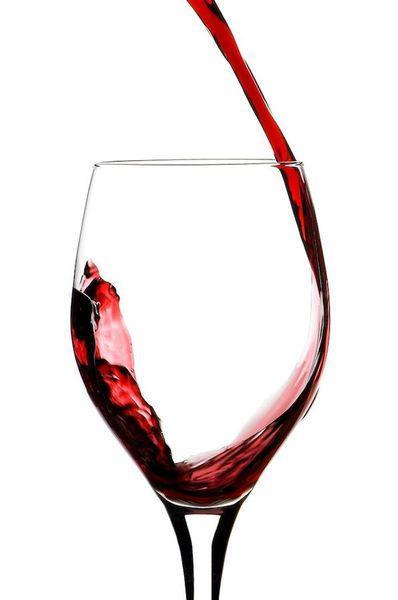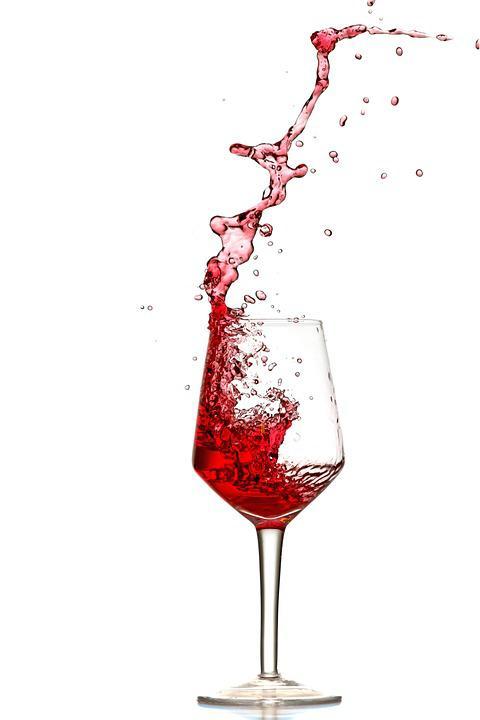The first image is the image on the left, the second image is the image on the right. Considering the images on both sides, is "At least one image has more than one wine glass in it." valid? Answer yes or no. No. 